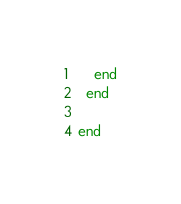Convert code to text. <code><loc_0><loc_0><loc_500><loc_500><_Elixir_>    end
  end

end
</code> 